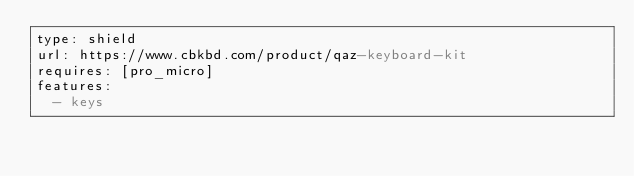<code> <loc_0><loc_0><loc_500><loc_500><_YAML_>type: shield
url: https://www.cbkbd.com/product/qaz-keyboard-kit
requires: [pro_micro]
features:
  - keys
</code> 